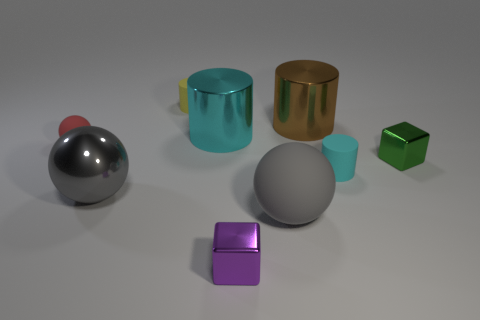Subtract all tiny yellow rubber cylinders. How many cylinders are left? 3 Subtract 2 spheres. How many spheres are left? 1 Subtract all red balls. How many balls are left? 2 Add 8 big gray rubber things. How many big gray rubber things are left? 9 Add 1 small purple metal things. How many small purple metal things exist? 2 Subtract 1 cyan cylinders. How many objects are left? 8 Subtract all cylinders. How many objects are left? 5 Subtract all red balls. Subtract all purple cylinders. How many balls are left? 2 Subtract all yellow spheres. How many green cubes are left? 1 Subtract all small purple rubber cylinders. Subtract all tiny purple shiny blocks. How many objects are left? 8 